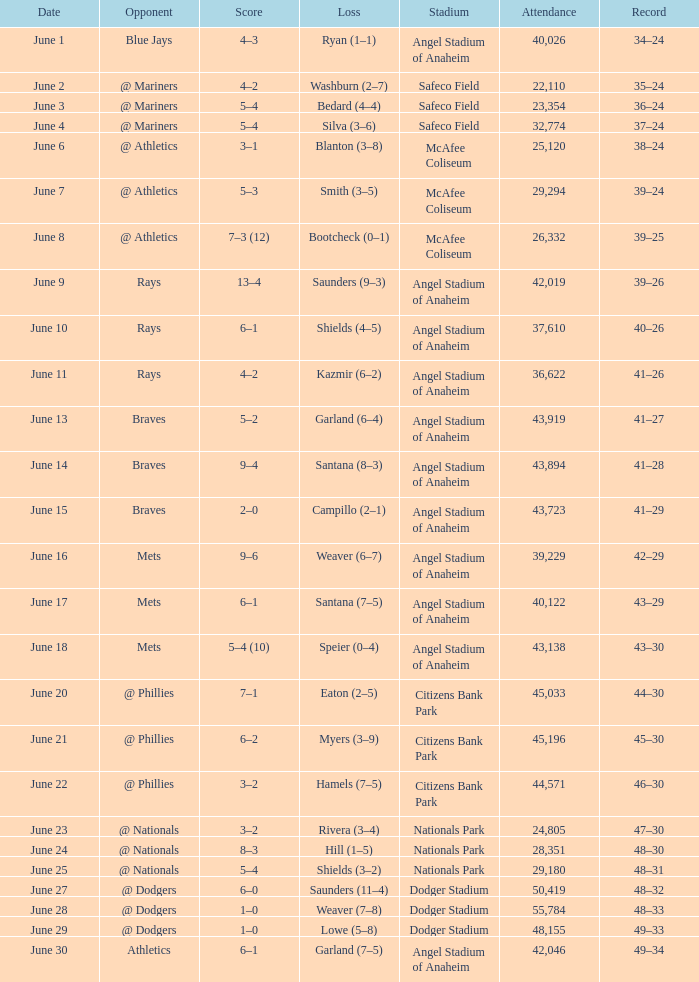Would you be able to parse every entry in this table? {'header': ['Date', 'Opponent', 'Score', 'Loss', 'Stadium', 'Attendance', 'Record'], 'rows': [['June 1', 'Blue Jays', '4–3', 'Ryan (1–1)', 'Angel Stadium of Anaheim', '40,026', '34–24'], ['June 2', '@ Mariners', '4–2', 'Washburn (2–7)', 'Safeco Field', '22,110', '35–24'], ['June 3', '@ Mariners', '5–4', 'Bedard (4–4)', 'Safeco Field', '23,354', '36–24'], ['June 4', '@ Mariners', '5–4', 'Silva (3–6)', 'Safeco Field', '32,774', '37–24'], ['June 6', '@ Athletics', '3–1', 'Blanton (3–8)', 'McAfee Coliseum', '25,120', '38–24'], ['June 7', '@ Athletics', '5–3', 'Smith (3–5)', 'McAfee Coliseum', '29,294', '39–24'], ['June 8', '@ Athletics', '7–3 (12)', 'Bootcheck (0–1)', 'McAfee Coliseum', '26,332', '39–25'], ['June 9', 'Rays', '13–4', 'Saunders (9–3)', 'Angel Stadium of Anaheim', '42,019', '39–26'], ['June 10', 'Rays', '6–1', 'Shields (4–5)', 'Angel Stadium of Anaheim', '37,610', '40–26'], ['June 11', 'Rays', '4–2', 'Kazmir (6–2)', 'Angel Stadium of Anaheim', '36,622', '41–26'], ['June 13', 'Braves', '5–2', 'Garland (6–4)', 'Angel Stadium of Anaheim', '43,919', '41–27'], ['June 14', 'Braves', '9–4', 'Santana (8–3)', 'Angel Stadium of Anaheim', '43,894', '41–28'], ['June 15', 'Braves', '2–0', 'Campillo (2–1)', 'Angel Stadium of Anaheim', '43,723', '41–29'], ['June 16', 'Mets', '9–6', 'Weaver (6–7)', 'Angel Stadium of Anaheim', '39,229', '42–29'], ['June 17', 'Mets', '6–1', 'Santana (7–5)', 'Angel Stadium of Anaheim', '40,122', '43–29'], ['June 18', 'Mets', '5–4 (10)', 'Speier (0–4)', 'Angel Stadium of Anaheim', '43,138', '43–30'], ['June 20', '@ Phillies', '7–1', 'Eaton (2–5)', 'Citizens Bank Park', '45,033', '44–30'], ['June 21', '@ Phillies', '6–2', 'Myers (3–9)', 'Citizens Bank Park', '45,196', '45–30'], ['June 22', '@ Phillies', '3–2', 'Hamels (7–5)', 'Citizens Bank Park', '44,571', '46–30'], ['June 23', '@ Nationals', '3–2', 'Rivera (3–4)', 'Nationals Park', '24,805', '47–30'], ['June 24', '@ Nationals', '8–3', 'Hill (1–5)', 'Nationals Park', '28,351', '48–30'], ['June 25', '@ Nationals', '5–4', 'Shields (3–2)', 'Nationals Park', '29,180', '48–31'], ['June 27', '@ Dodgers', '6–0', 'Saunders (11–4)', 'Dodger Stadium', '50,419', '48–32'], ['June 28', '@ Dodgers', '1–0', 'Weaver (7–8)', 'Dodger Stadium', '55,784', '48–33'], ['June 29', '@ Dodgers', '1–0', 'Lowe (5–8)', 'Dodger Stadium', '48,155', '49–33'], ['June 30', 'Athletics', '6–1', 'Garland (7–5)', 'Angel Stadium of Anaheim', '42,046', '49–34']]} What was the score of the game against the Braves with a record of 41–27? 5–2. 